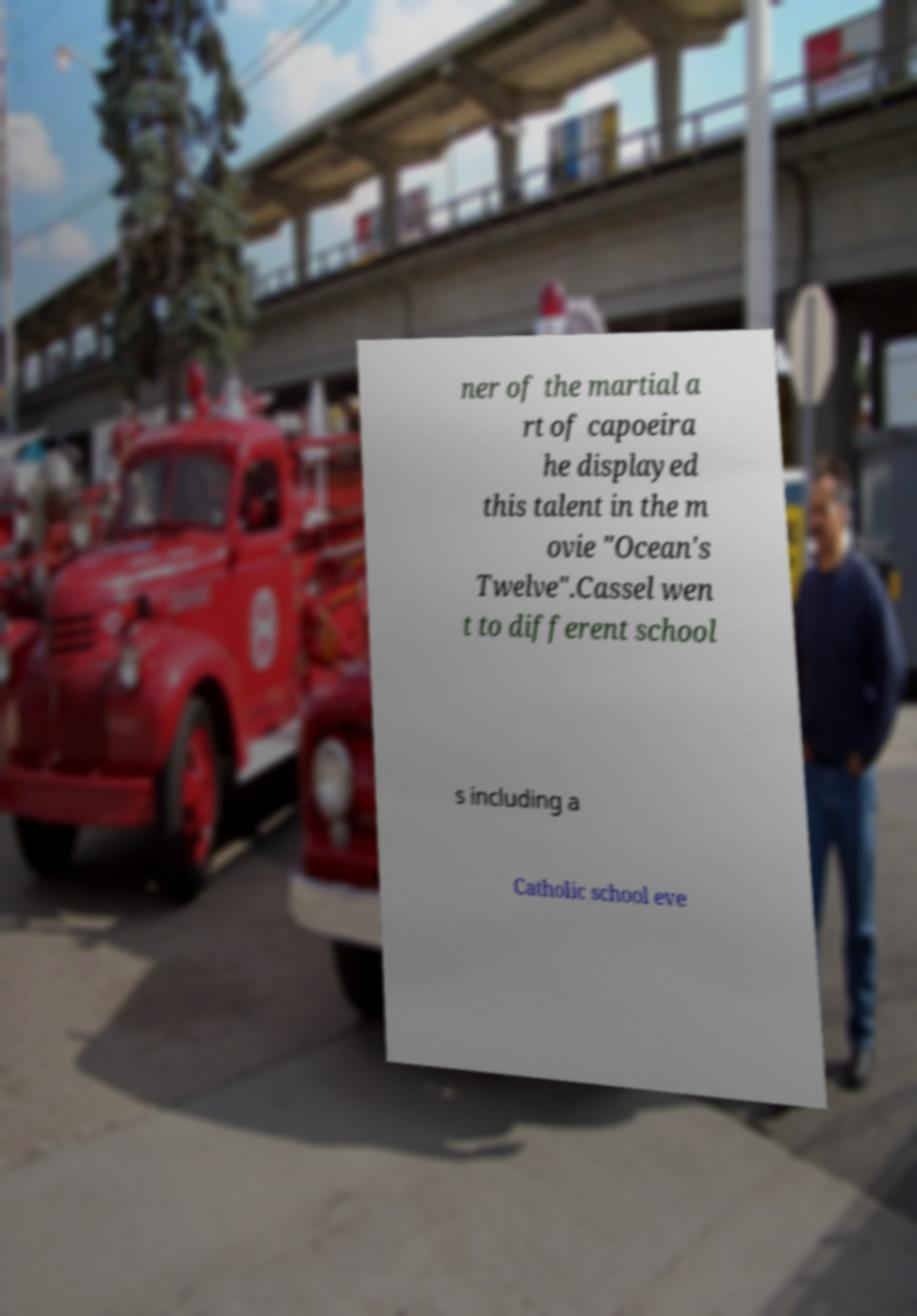Could you assist in decoding the text presented in this image and type it out clearly? ner of the martial a rt of capoeira he displayed this talent in the m ovie "Ocean's Twelve".Cassel wen t to different school s including a Catholic school eve 